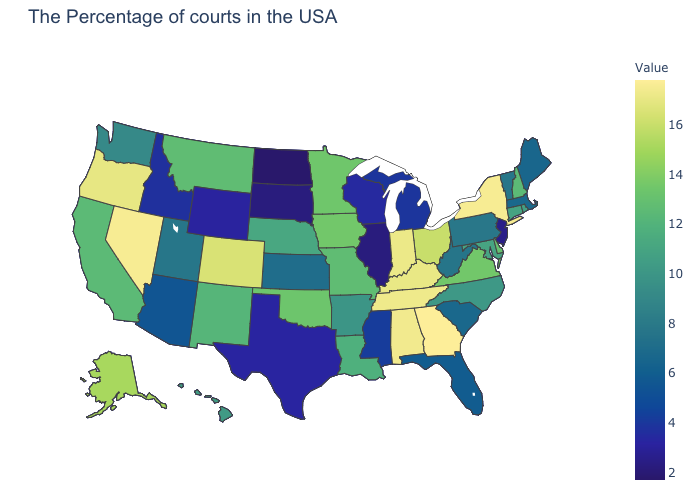Does Indiana have the highest value in the MidWest?
Concise answer only. Yes. Does Arkansas have the lowest value in the South?
Be succinct. No. Among the states that border New Mexico , does Colorado have the highest value?
Short answer required. Yes. 